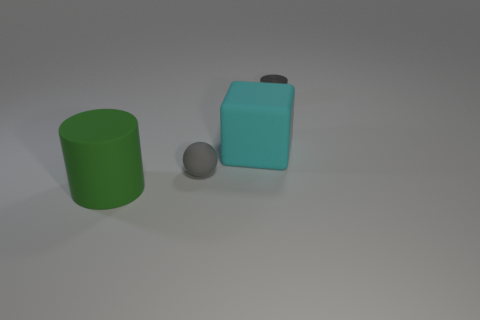Can you describe the lighting in the scene? The lighting in the scene is soft and diffused, providing even illumination without harsh shadows, likely suggesting an indoor setting with ambient light sources. How does the lighting affect the colors of the objects? The gentle lighting allows the true colors of the objects to be visible, with the green and cyan tones looking vivid yet not overly saturated, and the grey appearing neutral. 